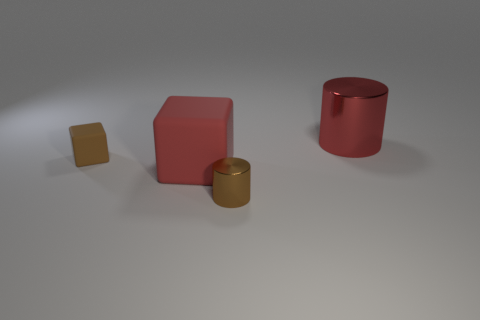Are there any brown matte things of the same shape as the big red matte object?
Give a very brief answer. Yes. Is the shape of the tiny metal object the same as the red object to the right of the red matte block?
Your answer should be compact. Yes. There is a object that is both in front of the brown rubber block and behind the tiny metal cylinder; what is its size?
Your answer should be compact. Large. How many metallic cylinders are there?
Make the answer very short. 2. There is a brown thing that is the same size as the brown cylinder; what material is it?
Provide a succinct answer. Rubber. Is there a green matte sphere that has the same size as the brown metallic object?
Provide a short and direct response. No. Do the metal object behind the tiny metal cylinder and the rubber block that is in front of the small rubber object have the same color?
Provide a succinct answer. Yes. What number of matte things are large objects or small blue spheres?
Make the answer very short. 1. There is a metallic object on the right side of the metallic object in front of the large red rubber object; how many large red cylinders are behind it?
Keep it short and to the point. 0. There is a object that is made of the same material as the large red cube; what is its size?
Your response must be concise. Small. 